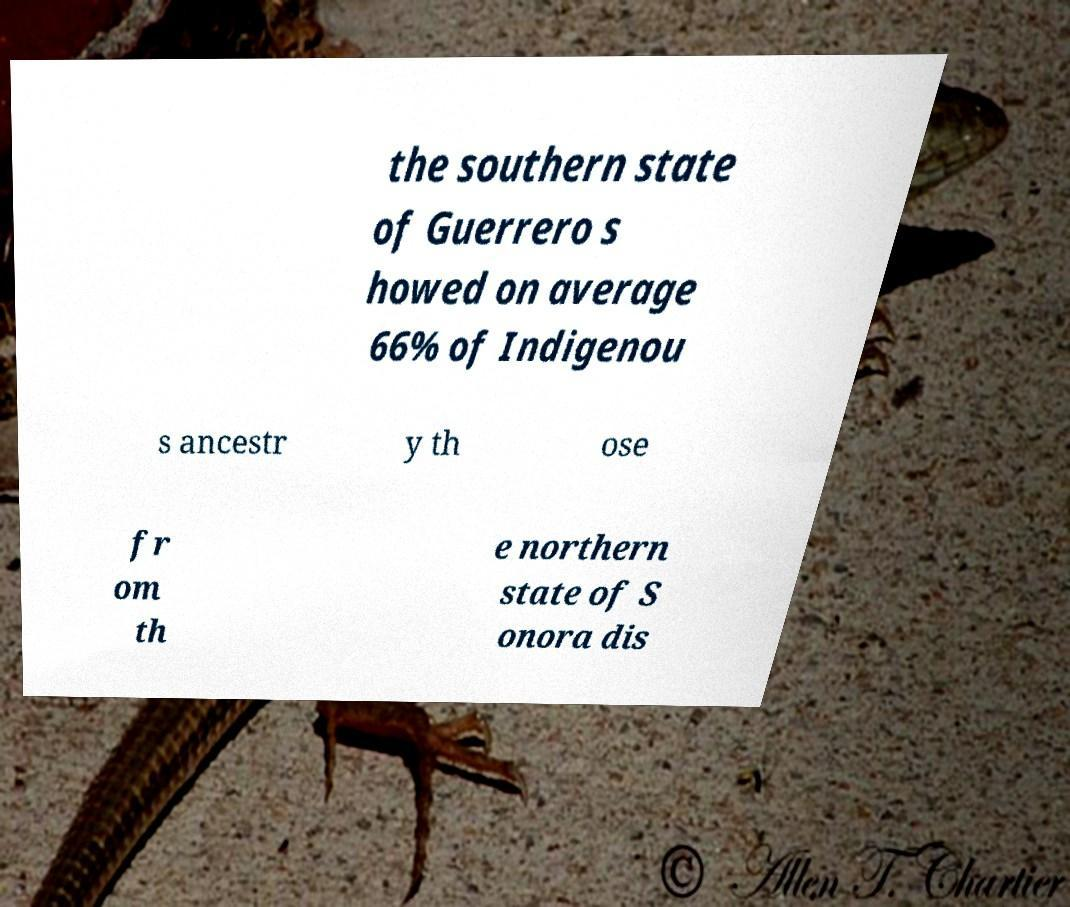Please identify and transcribe the text found in this image. the southern state of Guerrero s howed on average 66% of Indigenou s ancestr y th ose fr om th e northern state of S onora dis 